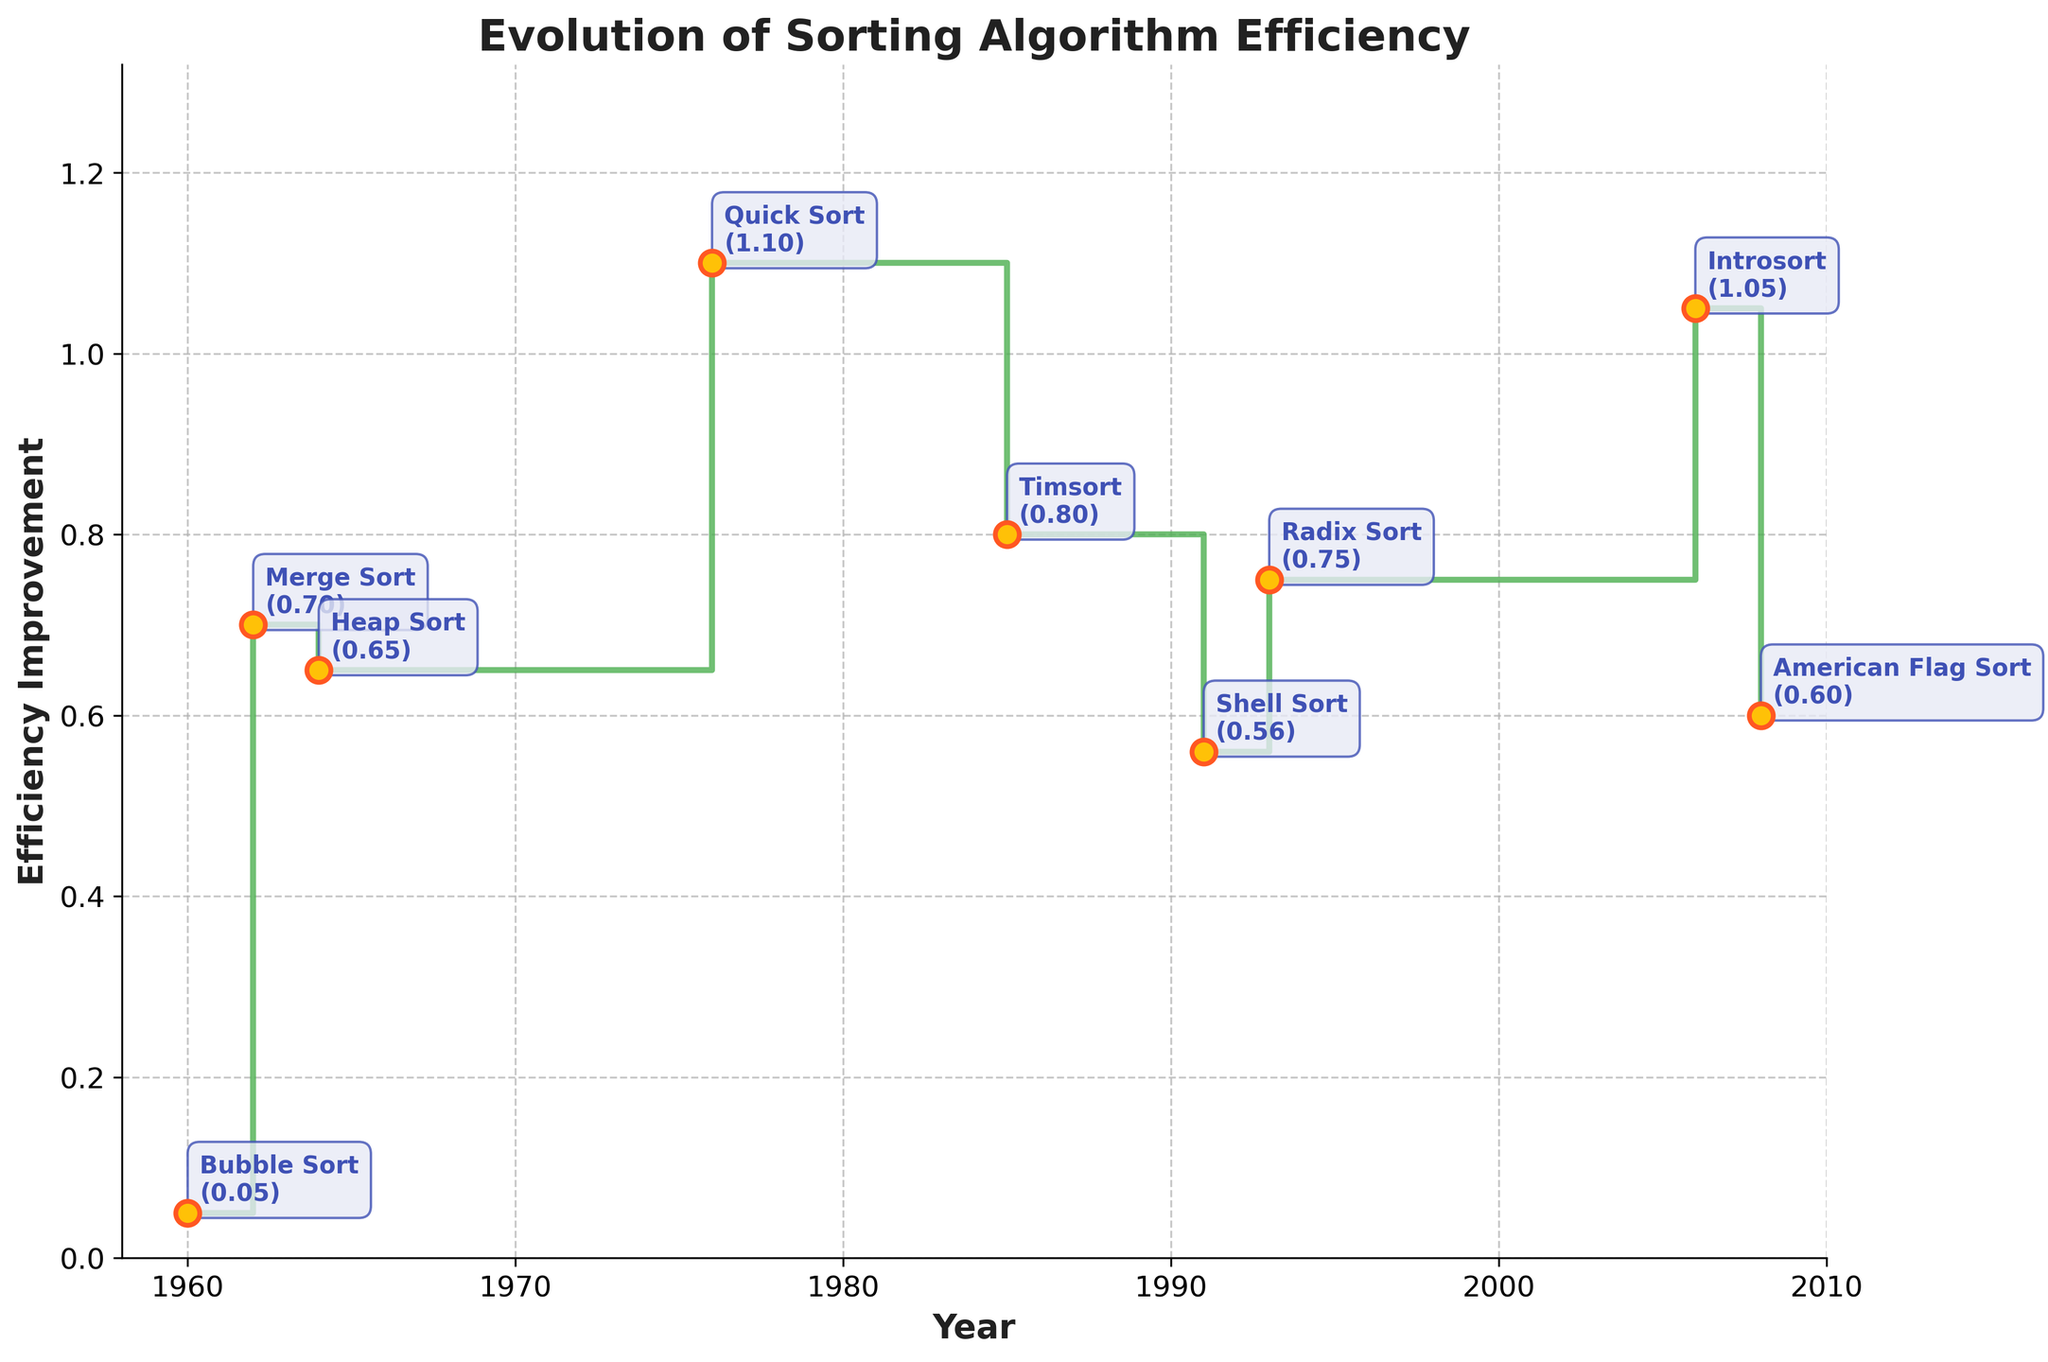How many different sorting algorithms are represented in the figure? By examining the annotations next to each data point, we can count 9 different sorting algorithms (Bubble Sort, Merge Sort, Heap Sort, Quick Sort, Timsort, Shell Sort, Radix Sort, Introsort, and American Flag Sort).
Answer: 9 What is the title of the figure? The title of the figure is located at the top of the plot. It reads "Evolution of Sorting Algorithm Efficiency".
Answer: Evolution of Sorting Algorithm Efficiency In which year did the algorithm with the highest efficiency improvement appear? By looking at the vertical position of the annotations, Quick Sort in 1976 has the highest efficiency improvement value (1.10).
Answer: 1976 Which algorithm has the lowest efficiency improvement and in what year did it appear? The lowest point in terms of efficiency improvement is Bubble Sort in 1960 with an improvement of 0.05.
Answer: Bubble Sort in 1960 Compare the efficiency improvements of Merge Sort and Introsort. Which one is higher and by how much? Merge Sort has an efficiency improvement of 0.70 and Introsort has 1.05. The difference is computed as 1.05 - 0.70 = 0.35.
Answer: Introsort is higher by 0.35 What is the average efficiency improvement of all the sorting algorithms presented in the figure? Summing the efficiency improvements (0.05 + 0.7 + 0.65 + 1.10 + 0.8 + 0.56 + 0.75 + 1.05 + 0.6 = 6.26) and dividing by the number of algorithms (9) gives the average: 6.26 / 9 ≈ 0.695.
Answer: ≈ 0.695 Describe the trend of improvements shown in the figure. Observing the plot, we can see a general increase in efficiency improvements over time, with some fluctuations. There is a significant jump in 1976 with Quick Sort, followed by generally high efficiency values in later years.
Answer: Increasing trend with fluctuations Identify the decade with the most frequent introduction of new sorting algorithms? Counting the algorithms in each decade: 1960s (3 algorithms), 1970s (1 algorithm), 1980s (1 algorithm), 1990s (2 algorithms), 2000s (2 algorithms). The 1960s had the most frequent introductions.
Answer: 1960s 